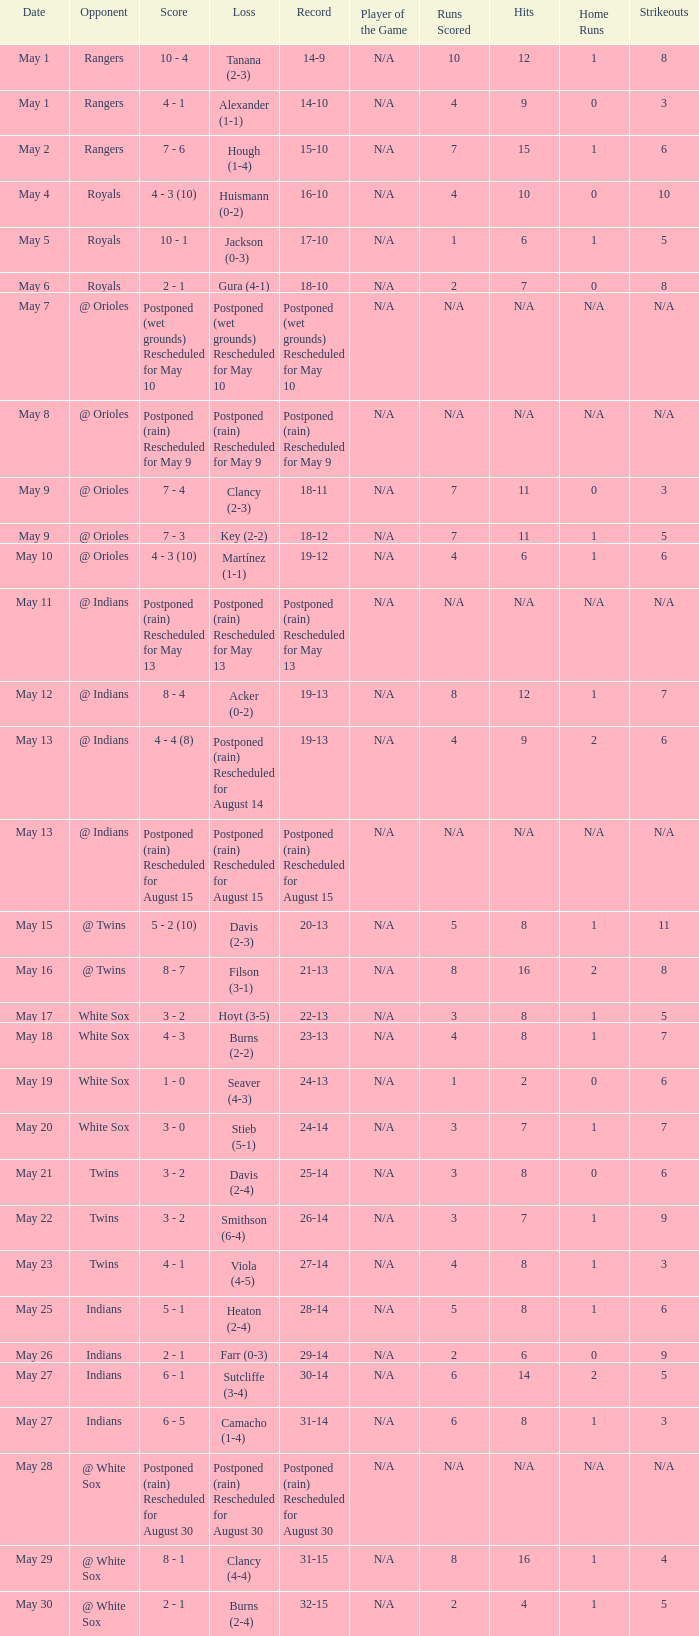What was the loss of the game when the record was 21-13? Filson (3-1). 